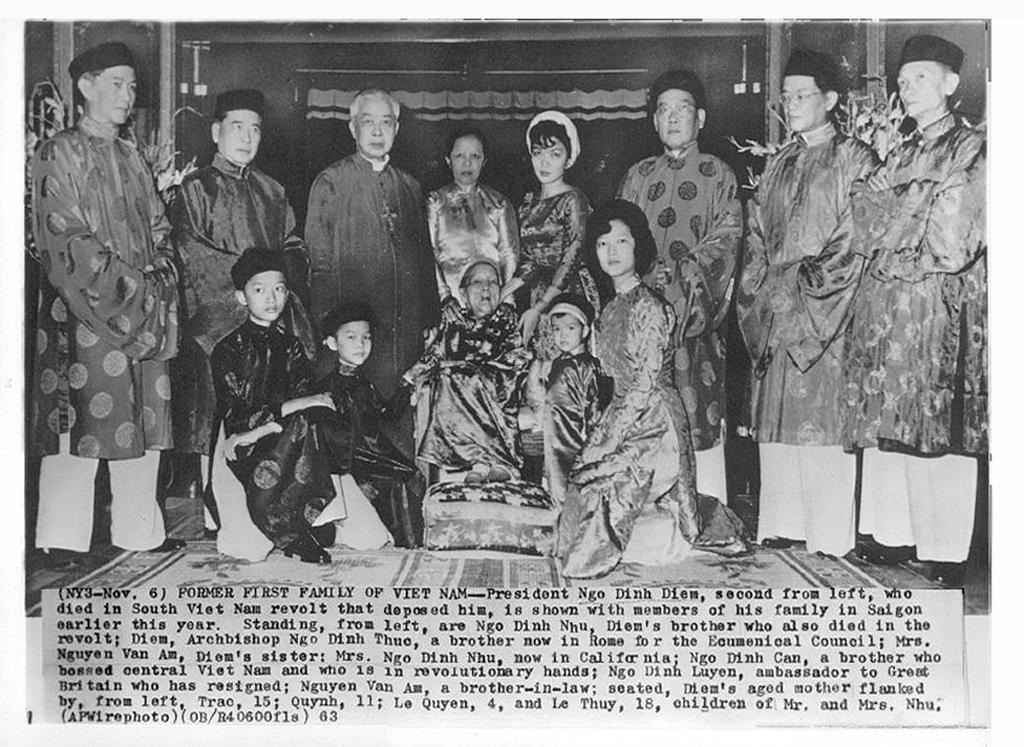What is the color scheme of the image? The image is black and white. How many people can be seen in the image? There are many people in the image. What are some of the people wearing in the image? Some people in the image are wearing caps. What can be found at the bottom of the image? There is text at the bottom of the image. How does the secretary maintain a quiet atmosphere in the image? There is no secretary present in the image, and therefore no such action can be observed. 